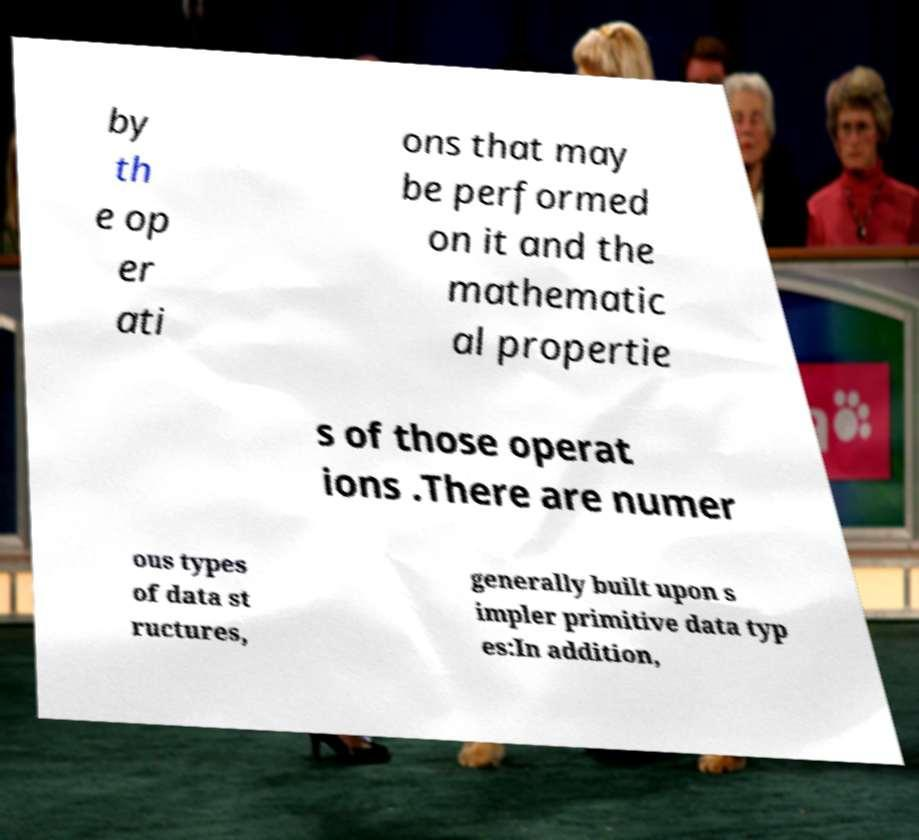Could you assist in decoding the text presented in this image and type it out clearly? by th e op er ati ons that may be performed on it and the mathematic al propertie s of those operat ions .There are numer ous types of data st ructures, generally built upon s impler primitive data typ es:In addition, 